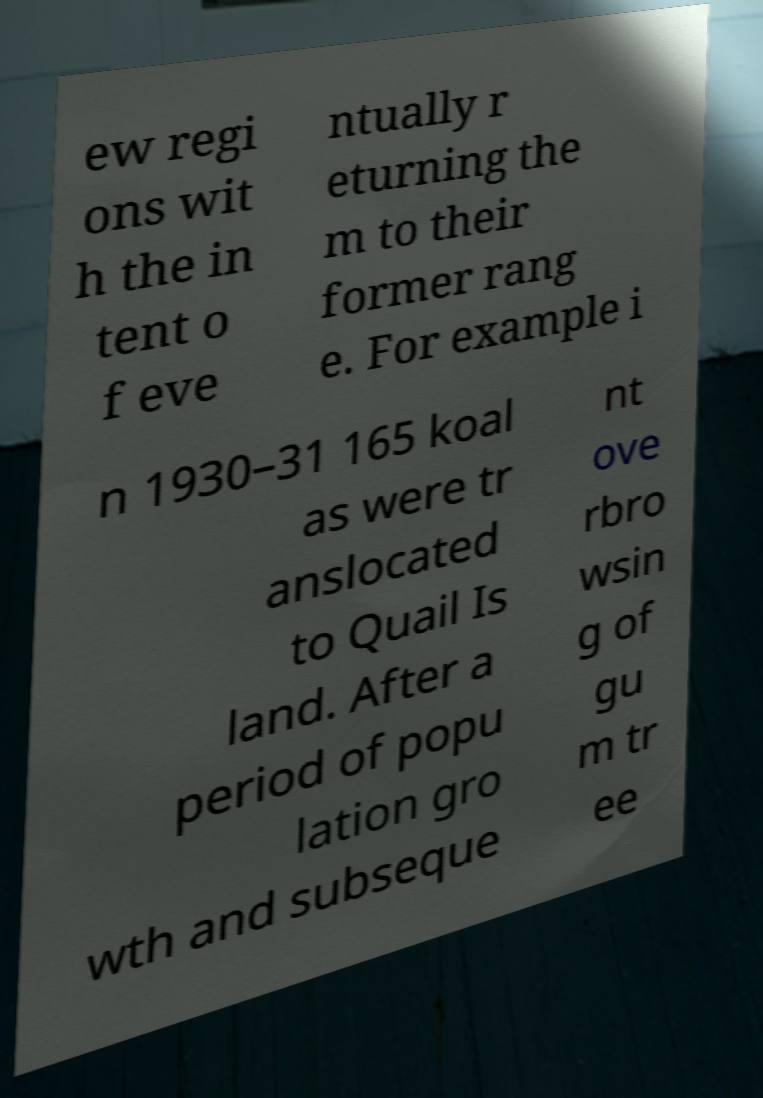Could you extract and type out the text from this image? ew regi ons wit h the in tent o f eve ntually r eturning the m to their former rang e. For example i n 1930–31 165 koal as were tr anslocated to Quail Is land. After a period of popu lation gro wth and subseque nt ove rbro wsin g of gu m tr ee 